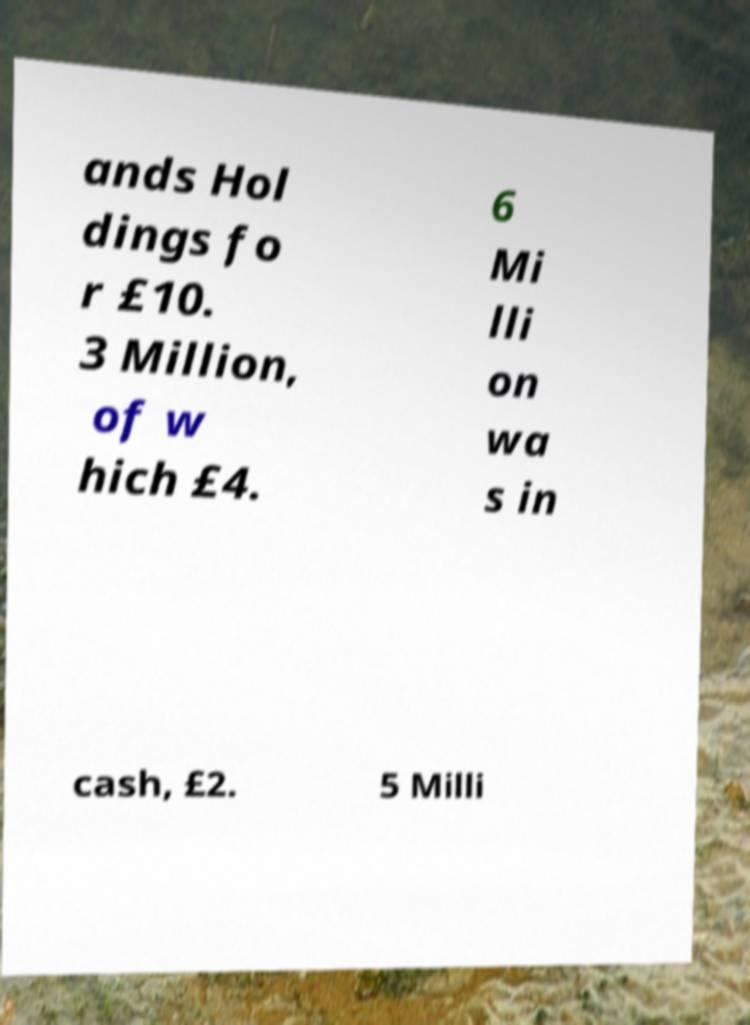Can you read and provide the text displayed in the image?This photo seems to have some interesting text. Can you extract and type it out for me? ands Hol dings fo r £10. 3 Million, of w hich £4. 6 Mi lli on wa s in cash, £2. 5 Milli 